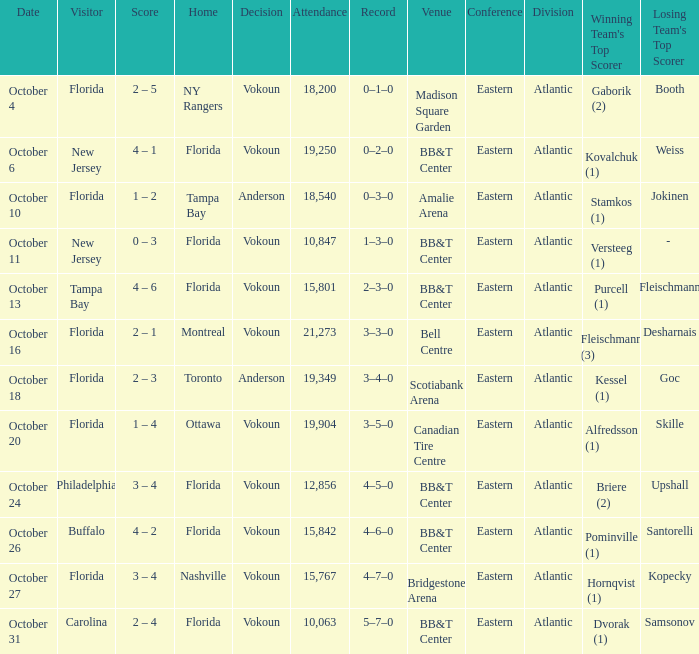Which team emerged victorious when the guest was carolina? Vokoun. 